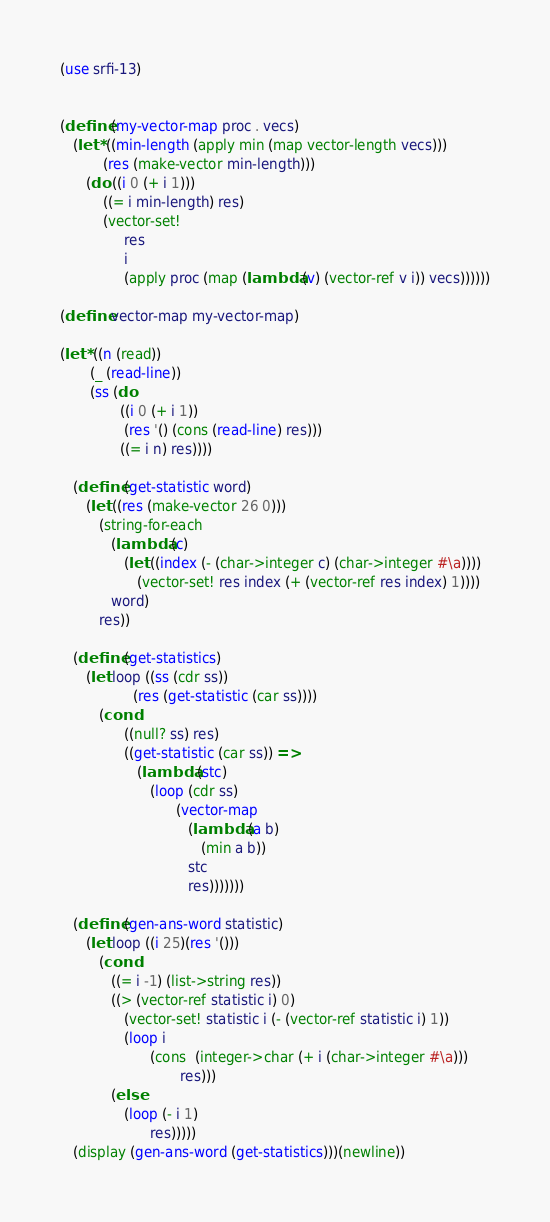Convert code to text. <code><loc_0><loc_0><loc_500><loc_500><_Scheme_>(use srfi-13)

 
(define (my-vector-map proc . vecs)
   (let* ((min-length (apply min (map vector-length vecs)))
          (res (make-vector min-length)))
      (do ((i 0 (+ i 1)))
          ((= i min-length) res)
          (vector-set!
               res
               i
               (apply proc (map (lambda (v) (vector-ref v i)) vecs))))))

(define vector-map my-vector-map)
 
(let* ((n (read))
       (_ (read-line))
       (ss (do 
              ((i 0 (+ i 1))
               (res '() (cons (read-line) res)))
              ((= i n) res))))

   (define (get-statistic word)
      (let ((res (make-vector 26 0)))
         (string-for-each
            (lambda (c)
               (let ((index (- (char->integer c) (char->integer #\a))))
                  (vector-set! res index (+ (vector-ref res index) 1))))
            word)
         res))

   (define (get-statistics)
      (let loop ((ss (cdr ss))
                 (res (get-statistic (car ss))))
         (cond
               ((null? ss) res)
               ((get-statistic (car ss)) =>
                  (lambda (stc)
                     (loop (cdr ss)
                           (vector-map
                              (lambda (a b)
                                 (min a b))
                              stc 
                              res)))))))

   (define (gen-ans-word statistic)
      (let loop ((i 25)(res '()))
         (cond 
            ((= i -1) (list->string res))
            ((> (vector-ref statistic i) 0)
               (vector-set! statistic i (- (vector-ref statistic i) 1))
               (loop i
                     (cons  (integer->char (+ i (char->integer #\a)))
                            res)))
            (else
               (loop (- i 1)
                     res)))))
   (display (gen-ans-word (get-statistics)))(newline))
</code> 